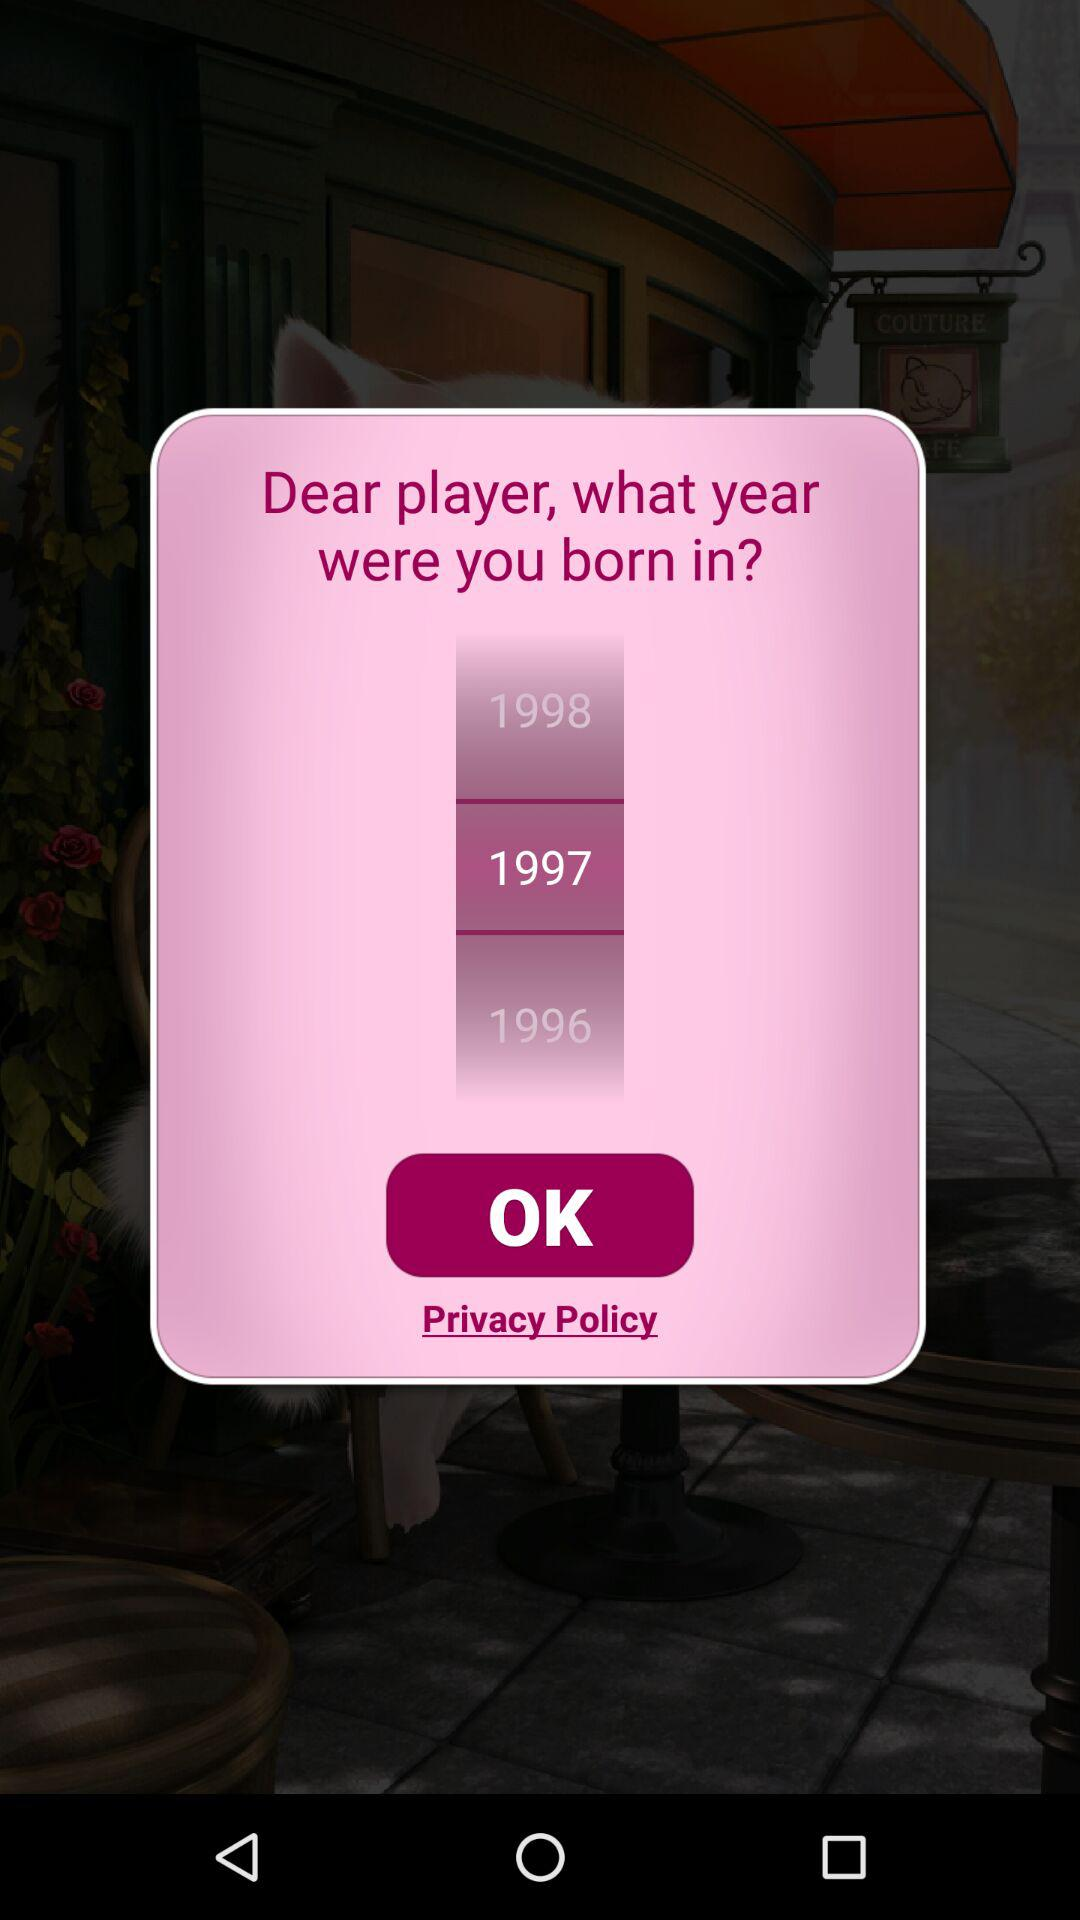What is the birth year of the player? The birth year of the player is 1997. 